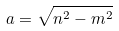Convert formula to latex. <formula><loc_0><loc_0><loc_500><loc_500>a = \sqrt { n ^ { 2 } - m ^ { 2 } }</formula> 